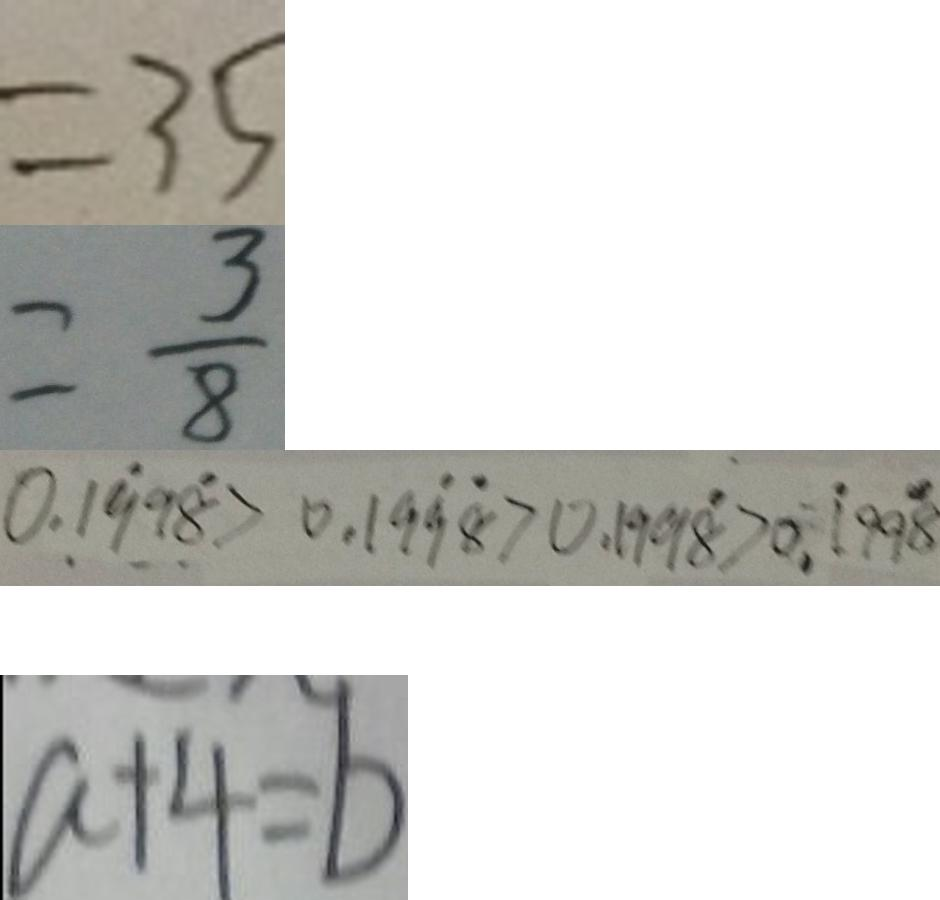Convert formula to latex. <formula><loc_0><loc_0><loc_500><loc_500>= 3 5 
 = \frac { 3 } { 8 } 
 0 . 1 \dot { 9 } 9 \dot { 8 } > 0 . 1 9 \dot { 9 } \dot { 8 } > 0 . 1 9 9 \dot { 8 } > 0 . \dot { 1 } 9 9 \dot { 8 } 
 a + 4 = b</formula> 